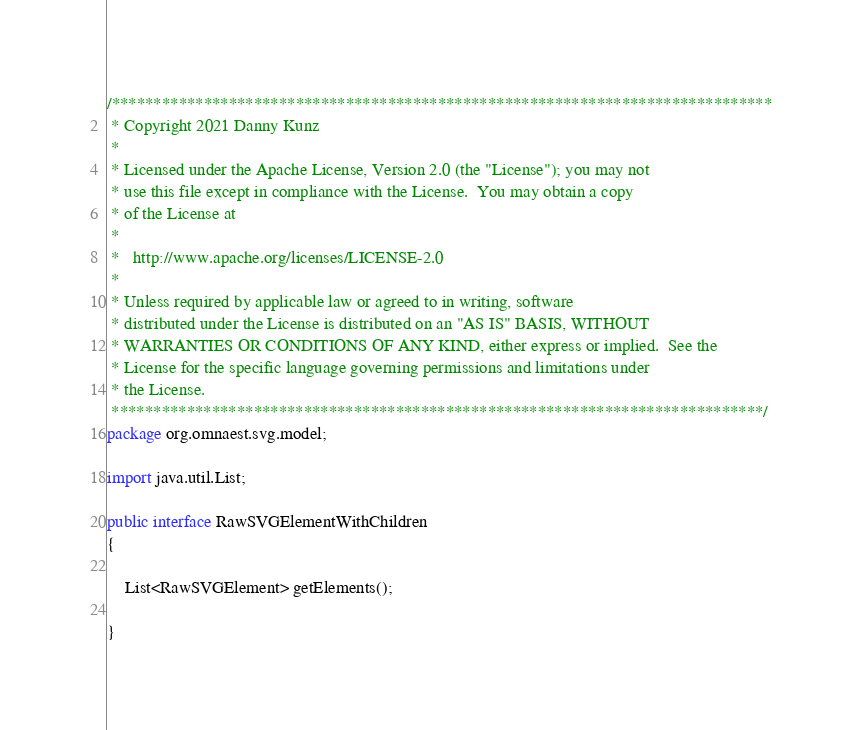<code> <loc_0><loc_0><loc_500><loc_500><_Java_>/*******************************************************************************
 * Copyright 2021 Danny Kunz
 * 
 * Licensed under the Apache License, Version 2.0 (the "License"); you may not
 * use this file except in compliance with the License.  You may obtain a copy
 * of the License at
 * 
 *   http://www.apache.org/licenses/LICENSE-2.0
 * 
 * Unless required by applicable law or agreed to in writing, software
 * distributed under the License is distributed on an "AS IS" BASIS, WITHOUT
 * WARRANTIES OR CONDITIONS OF ANY KIND, either express or implied.  See the
 * License for the specific language governing permissions and limitations under
 * the License.
 ******************************************************************************/
package org.omnaest.svg.model;

import java.util.List;

public interface RawSVGElementWithChildren
{

    List<RawSVGElement> getElements();

}
</code> 